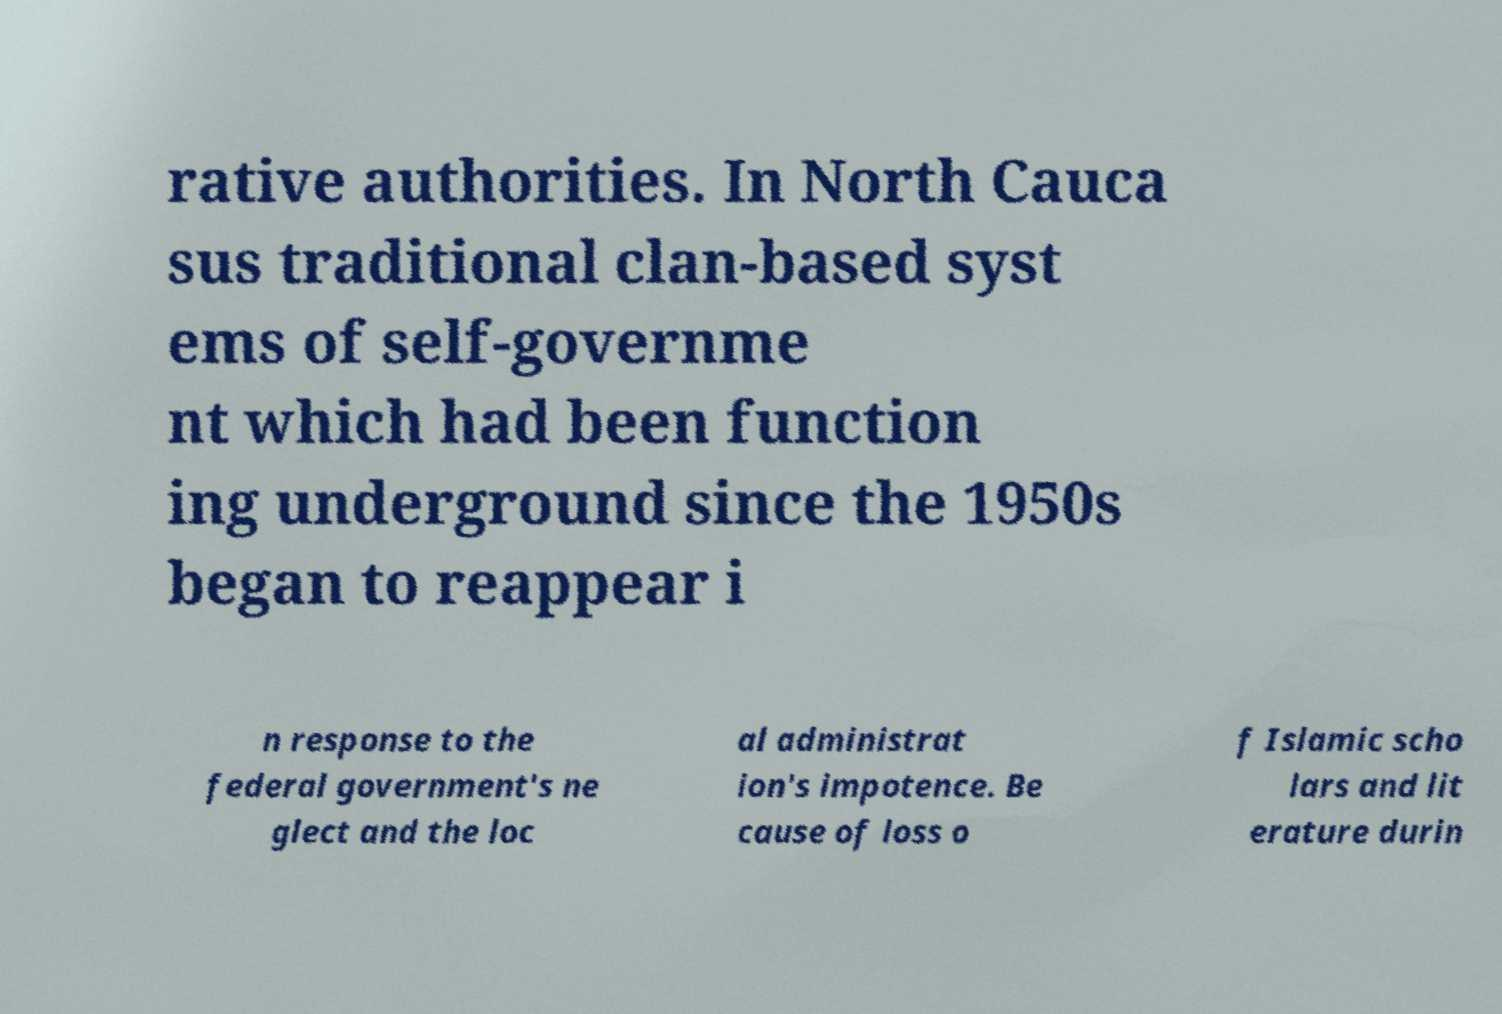For documentation purposes, I need the text within this image transcribed. Could you provide that? rative authorities. In North Cauca sus traditional clan-based syst ems of self-governme nt which had been function ing underground since the 1950s began to reappear i n response to the federal government's ne glect and the loc al administrat ion's impotence. Be cause of loss o f Islamic scho lars and lit erature durin 